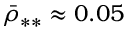Convert formula to latex. <formula><loc_0><loc_0><loc_500><loc_500>\bar { \rho } _ { * * } \approx 0 . 0 5</formula> 